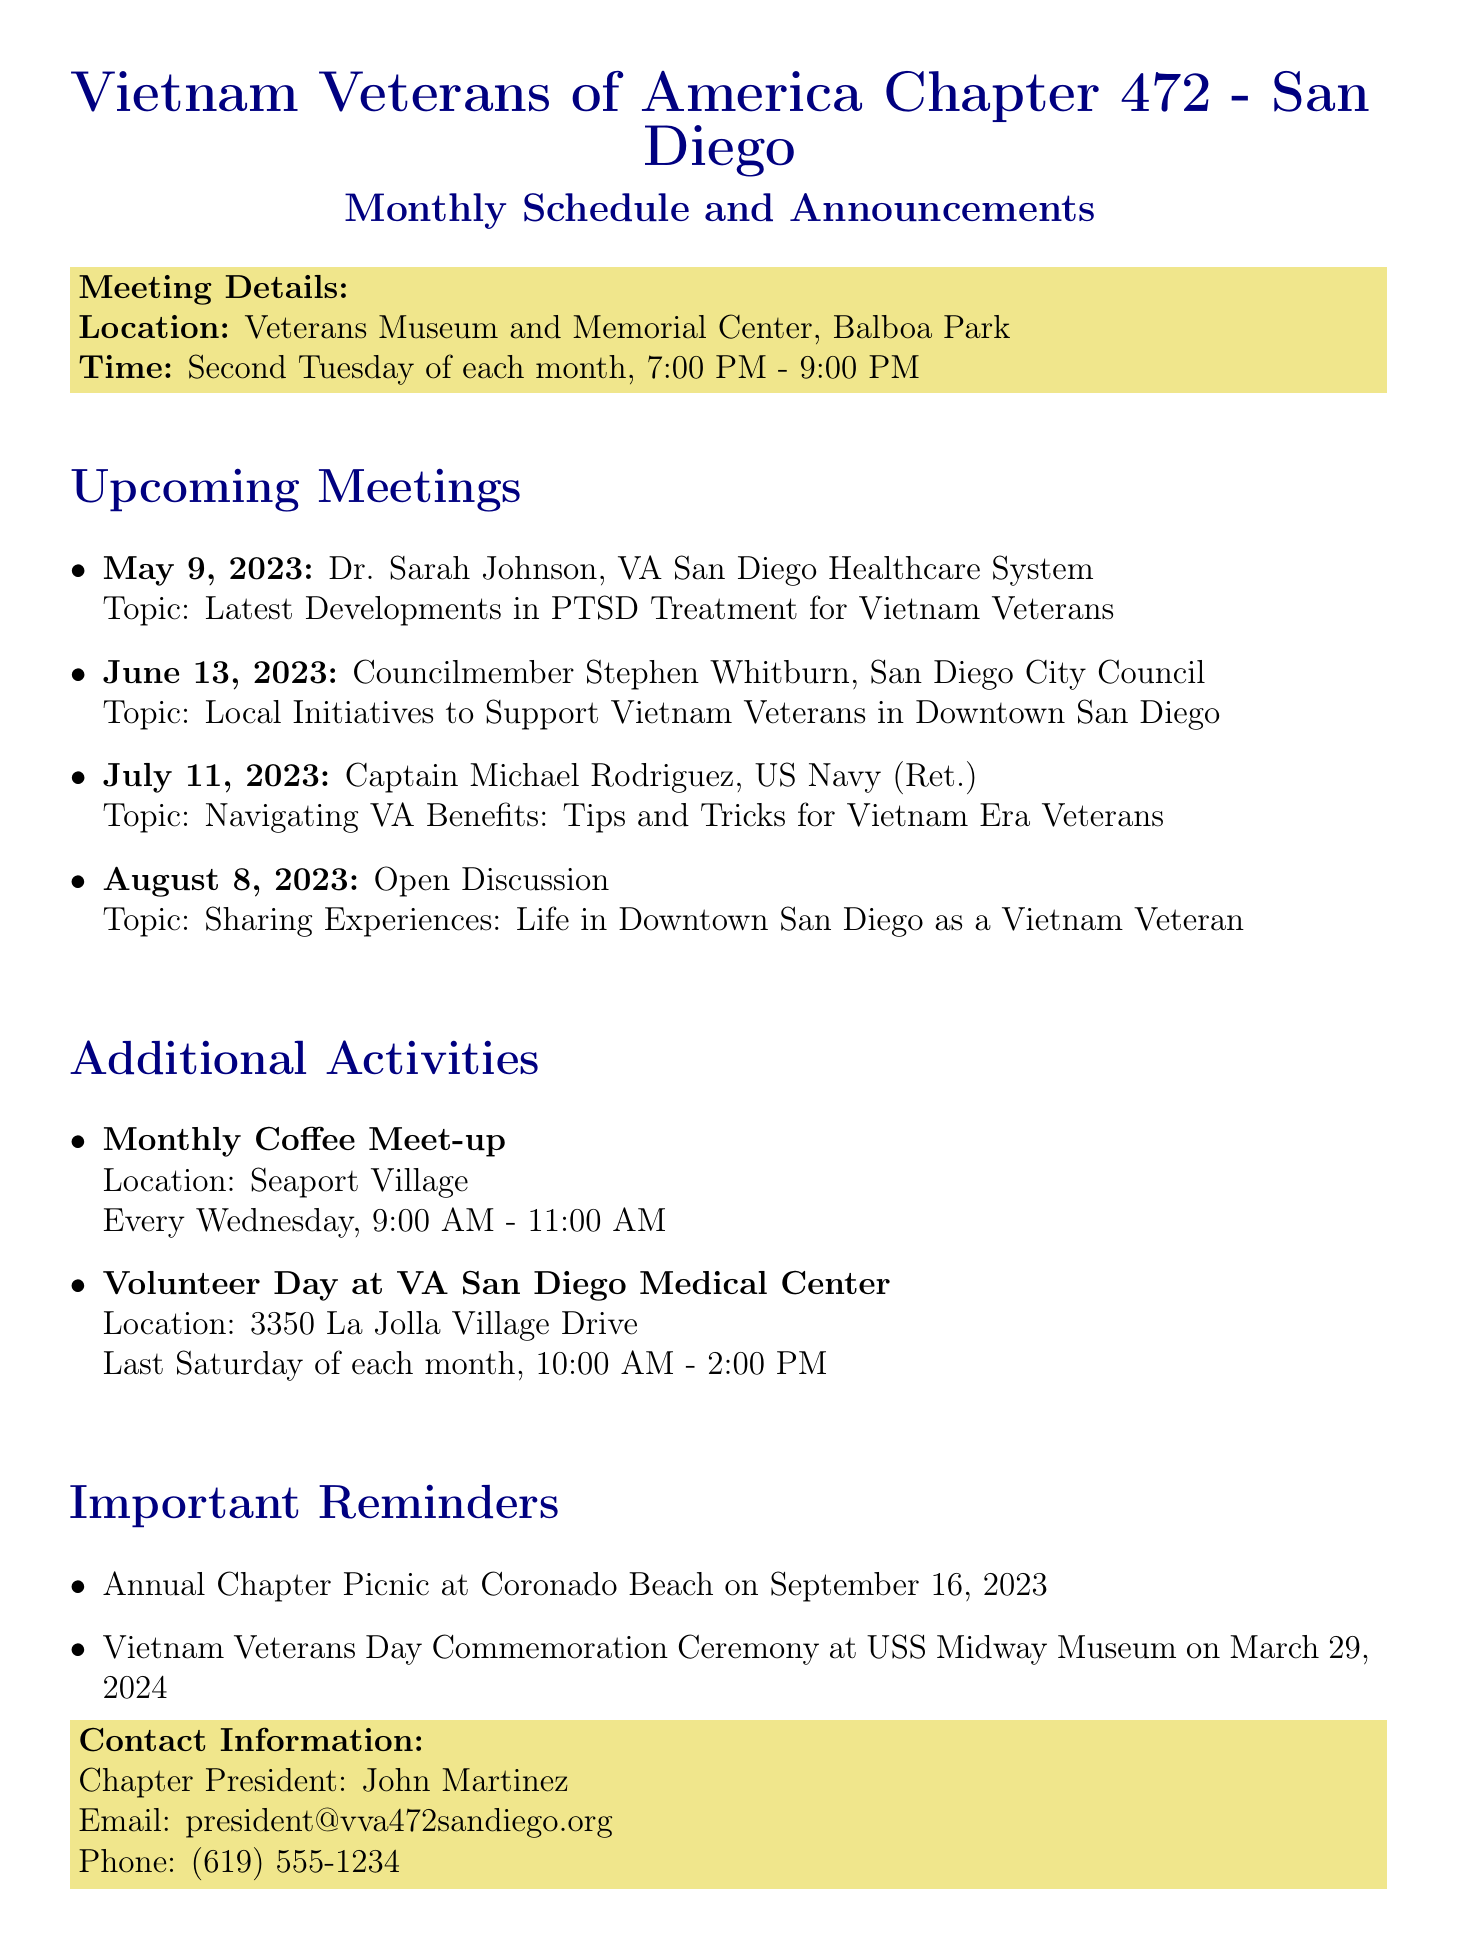What is the name of the chapter? The chapter is referred to as the Vietnam Veterans of America Chapter 472 - San Diego.
Answer: Vietnam Veterans of America Chapter 472 - San Diego Where does the chapter meet? The meeting location is specified as the Veterans Museum and Memorial Center in Balboa Park.
Answer: Veterans Museum and Memorial Center, Balboa Park Who is the guest speaker for July 2023? The document provides the name of the guest speaker for July, which is Captain Michael Rodriguez, US Navy (Ret.).
Answer: Captain Michael Rodriguez, US Navy (Ret.) What is the topic of discussion for the August 2023 meeting? The August meeting is designated for an Open Discussion, focusing on sharing experiences as Vietnam Veterans in downtown San Diego.
Answer: Sharing Experiences: Life in Downtown San Diego as a Vietnam Veteran When is the Annual Chapter Picnic scheduled? The document mentions that the Annual Chapter Picnic will take place on September 16, 2023.
Answer: September 16, 2023 How often does the Monthly Coffee Meet-up occur? The document indicates that the Monthly Coffee Meet-up is scheduled for every Wednesday.
Answer: Every Wednesday What additional activity takes place at VA San Diego Medical Center? The document lists a Volunteer Day as an additional activity at VA San Diego Medical Center.
Answer: Volunteer Day at VA San Diego Medical Center Who is the chapter president? The chapter president's name is provided as John Martinez.
Answer: John Martinez 